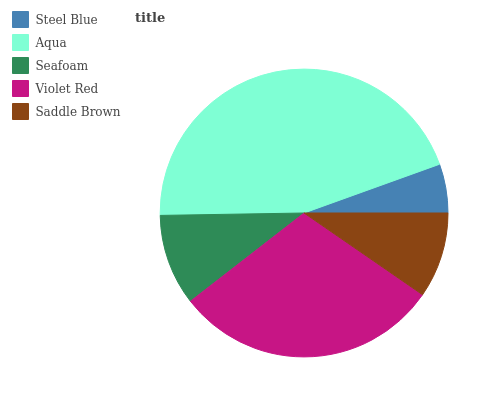Is Steel Blue the minimum?
Answer yes or no. Yes. Is Aqua the maximum?
Answer yes or no. Yes. Is Seafoam the minimum?
Answer yes or no. No. Is Seafoam the maximum?
Answer yes or no. No. Is Aqua greater than Seafoam?
Answer yes or no. Yes. Is Seafoam less than Aqua?
Answer yes or no. Yes. Is Seafoam greater than Aqua?
Answer yes or no. No. Is Aqua less than Seafoam?
Answer yes or no. No. Is Seafoam the high median?
Answer yes or no. Yes. Is Seafoam the low median?
Answer yes or no. Yes. Is Steel Blue the high median?
Answer yes or no. No. Is Steel Blue the low median?
Answer yes or no. No. 